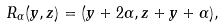Convert formula to latex. <formula><loc_0><loc_0><loc_500><loc_500>R _ { \alpha } ( y , z ) = ( y + 2 \alpha , z + y + \alpha ) ,</formula> 